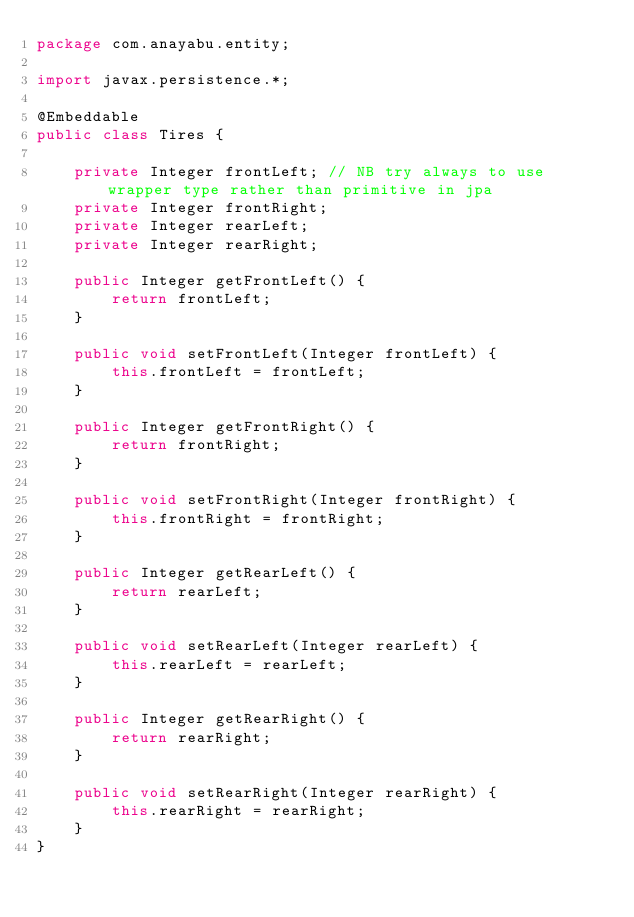<code> <loc_0><loc_0><loc_500><loc_500><_Java_>package com.anayabu.entity;

import javax.persistence.*;

@Embeddable
public class Tires {

    private Integer frontLeft; // NB try always to use wrapper type rather than primitive in jpa
    private Integer frontRight;
    private Integer rearLeft;
    private Integer rearRight;

    public Integer getFrontLeft() {
        return frontLeft;
    }

    public void setFrontLeft(Integer frontLeft) {
        this.frontLeft = frontLeft;
    }

    public Integer getFrontRight() {
        return frontRight;
    }

    public void setFrontRight(Integer frontRight) {
        this.frontRight = frontRight;
    }

    public Integer getRearLeft() {
        return rearLeft;
    }

    public void setRearLeft(Integer rearLeft) {
        this.rearLeft = rearLeft;
    }

    public Integer getRearRight() {
        return rearRight;
    }

    public void setRearRight(Integer rearRight) {
        this.rearRight = rearRight;
    }
}
</code> 